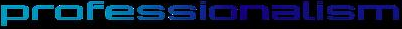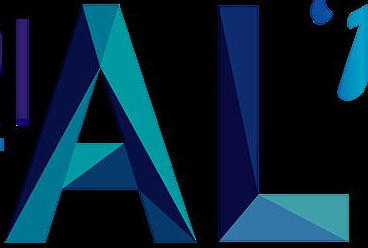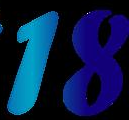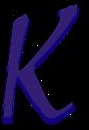What text appears in these images from left to right, separated by a semicolon? professionalism; AL; 18; k 